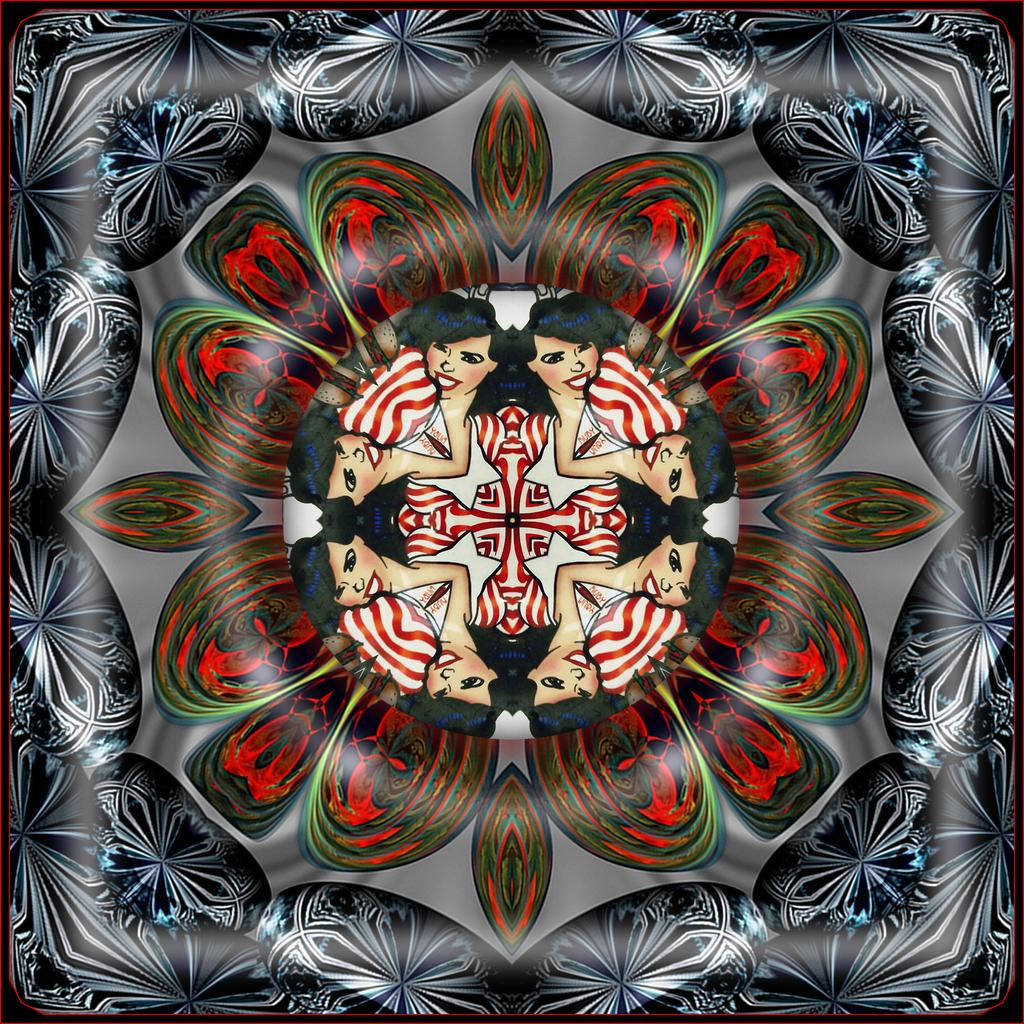What type of artwork is shown in the image? The image is a painting. Who or what is depicted in the painting? There are women depicted in the painting. Are there any specific objects or elements in the painting? Yes, there is a flower and other designs in the painting. What is the color of the background in the painting? The background of the painting is gray in color. Is there any blood visible in the painting? No, there is no blood present in the painting. What type of plants are growing in the painting? There are no plants depicted in the painting, only a single flower. 